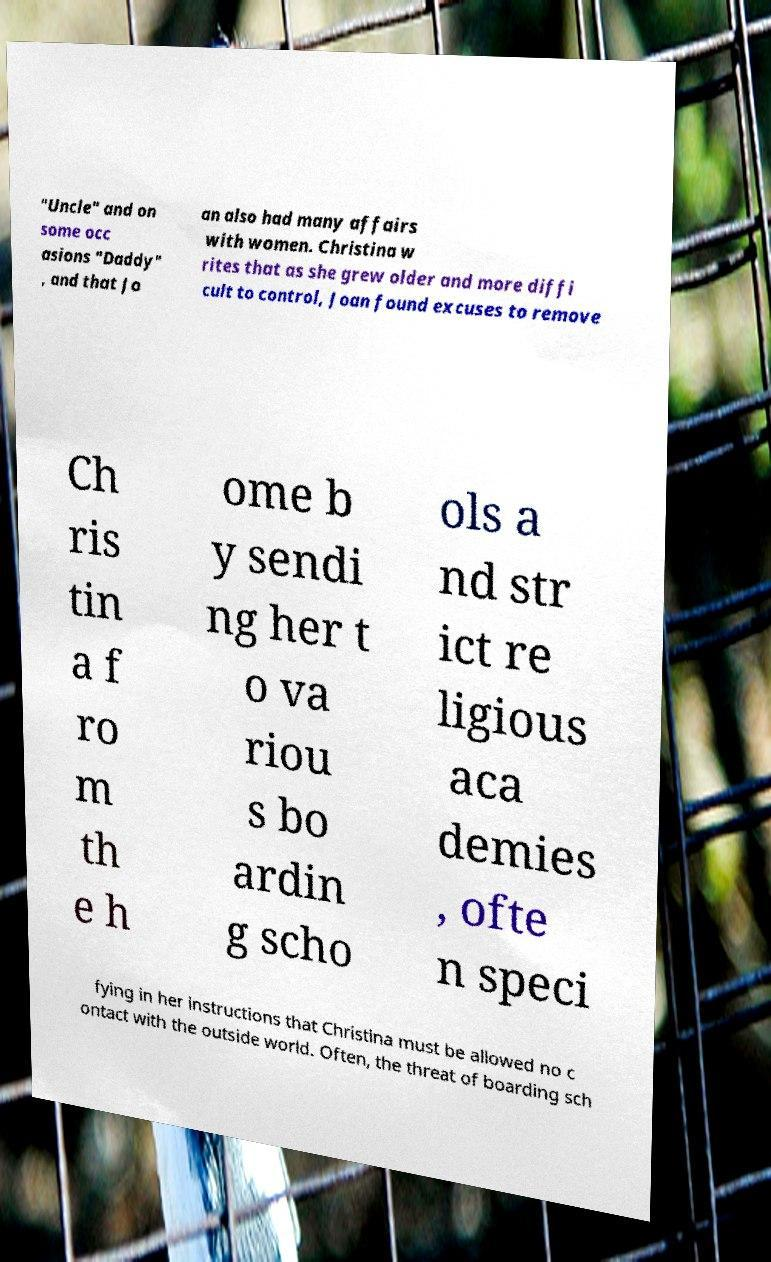For documentation purposes, I need the text within this image transcribed. Could you provide that? "Uncle" and on some occ asions "Daddy" , and that Jo an also had many affairs with women. Christina w rites that as she grew older and more diffi cult to control, Joan found excuses to remove Ch ris tin a f ro m th e h ome b y sendi ng her t o va riou s bo ardin g scho ols a nd str ict re ligious aca demies , ofte n speci fying in her instructions that Christina must be allowed no c ontact with the outside world. Often, the threat of boarding sch 